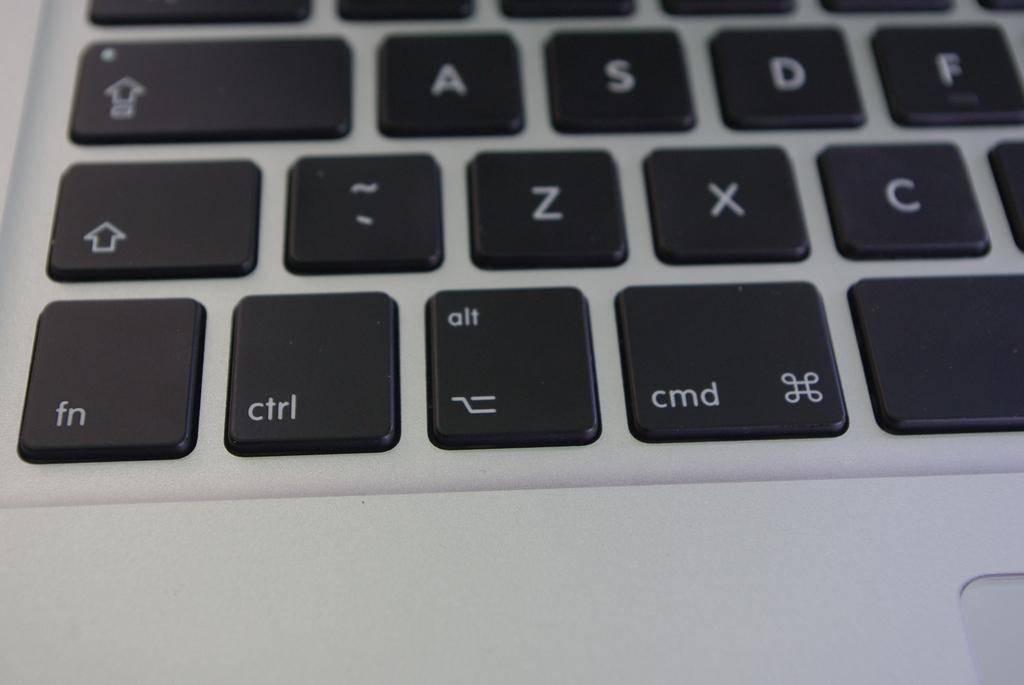<image>
Describe the image concisely. A laptop keyboard has a fn key below a shift key. 